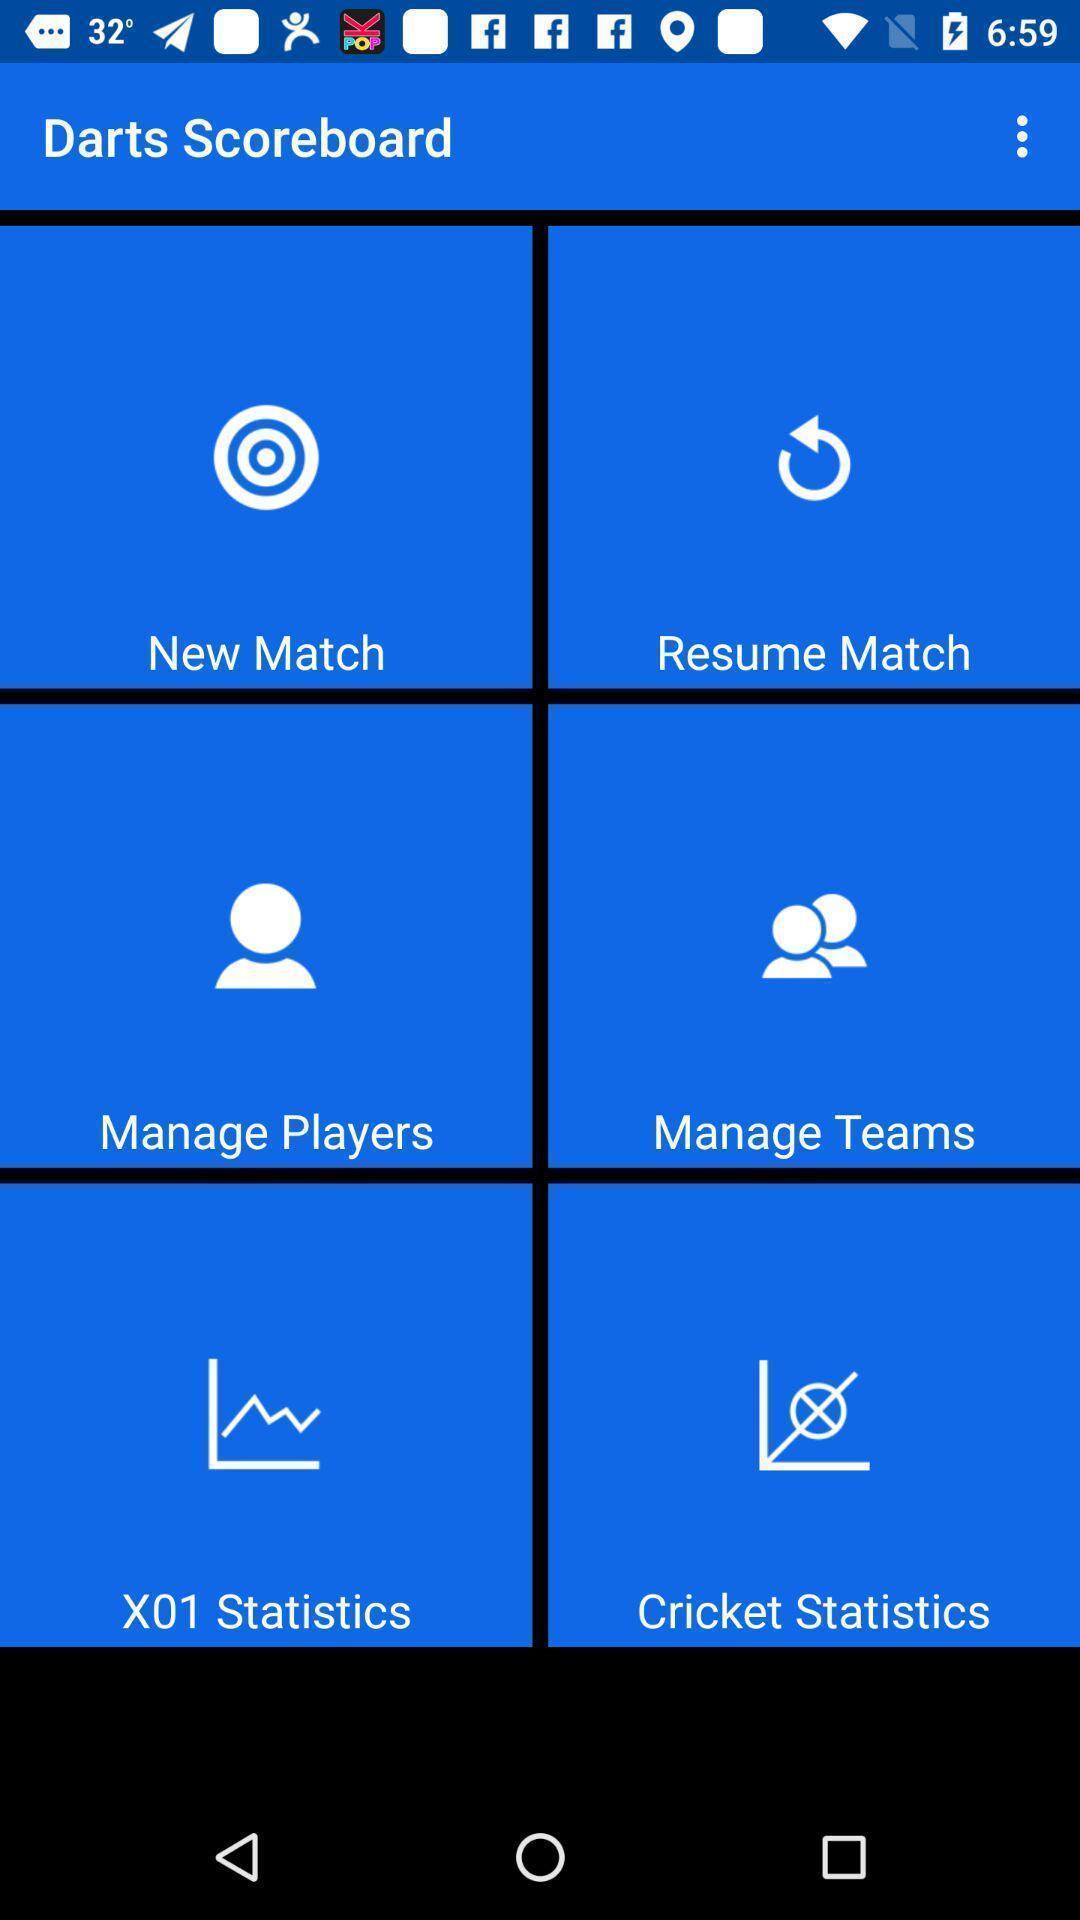Provide a description of this screenshot. Page displaying list of options in app. 